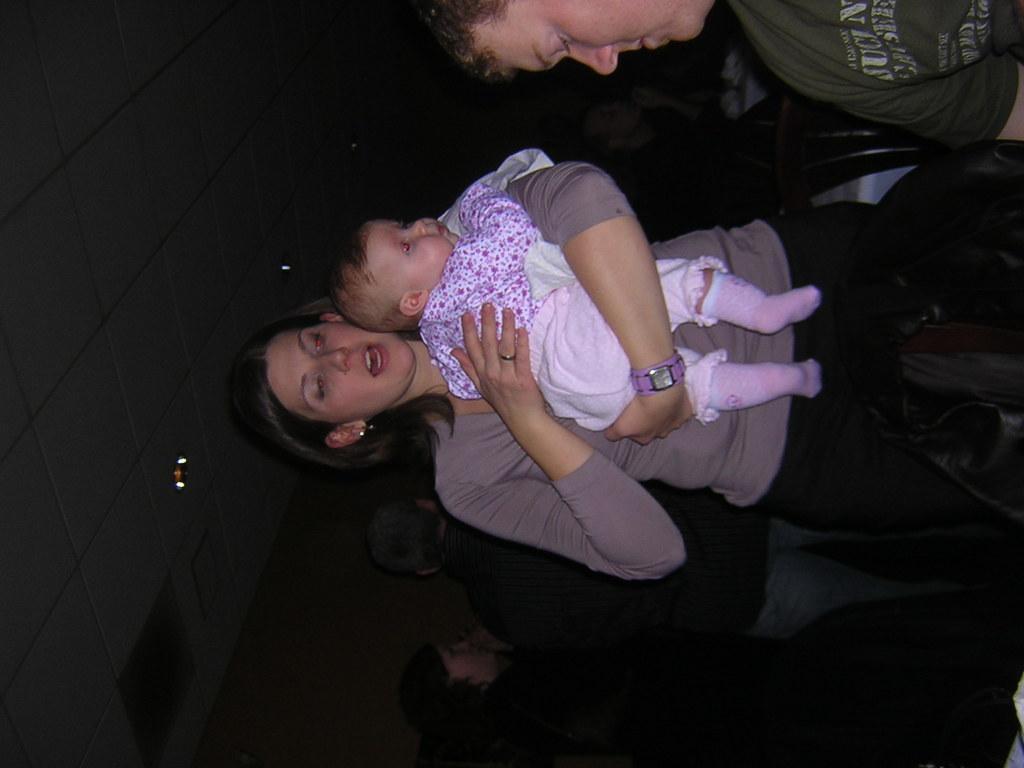Please provide a concise description of this image. In this image I can see the group of people with different color dresses. To the left I can see the lights and the wall. 